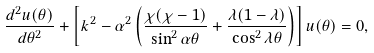Convert formula to latex. <formula><loc_0><loc_0><loc_500><loc_500>\frac { d ^ { 2 } u ( \theta ) } { d \theta ^ { 2 } } + \left [ k ^ { 2 } - \alpha ^ { 2 } \left ( \frac { \chi ( \chi - 1 ) } { \sin ^ { 2 } \alpha \theta } + \frac { \lambda ( 1 - \lambda ) } { \cos ^ { 2 } \lambda \theta } \right ) \right ] u ( \theta ) = 0 ,</formula> 